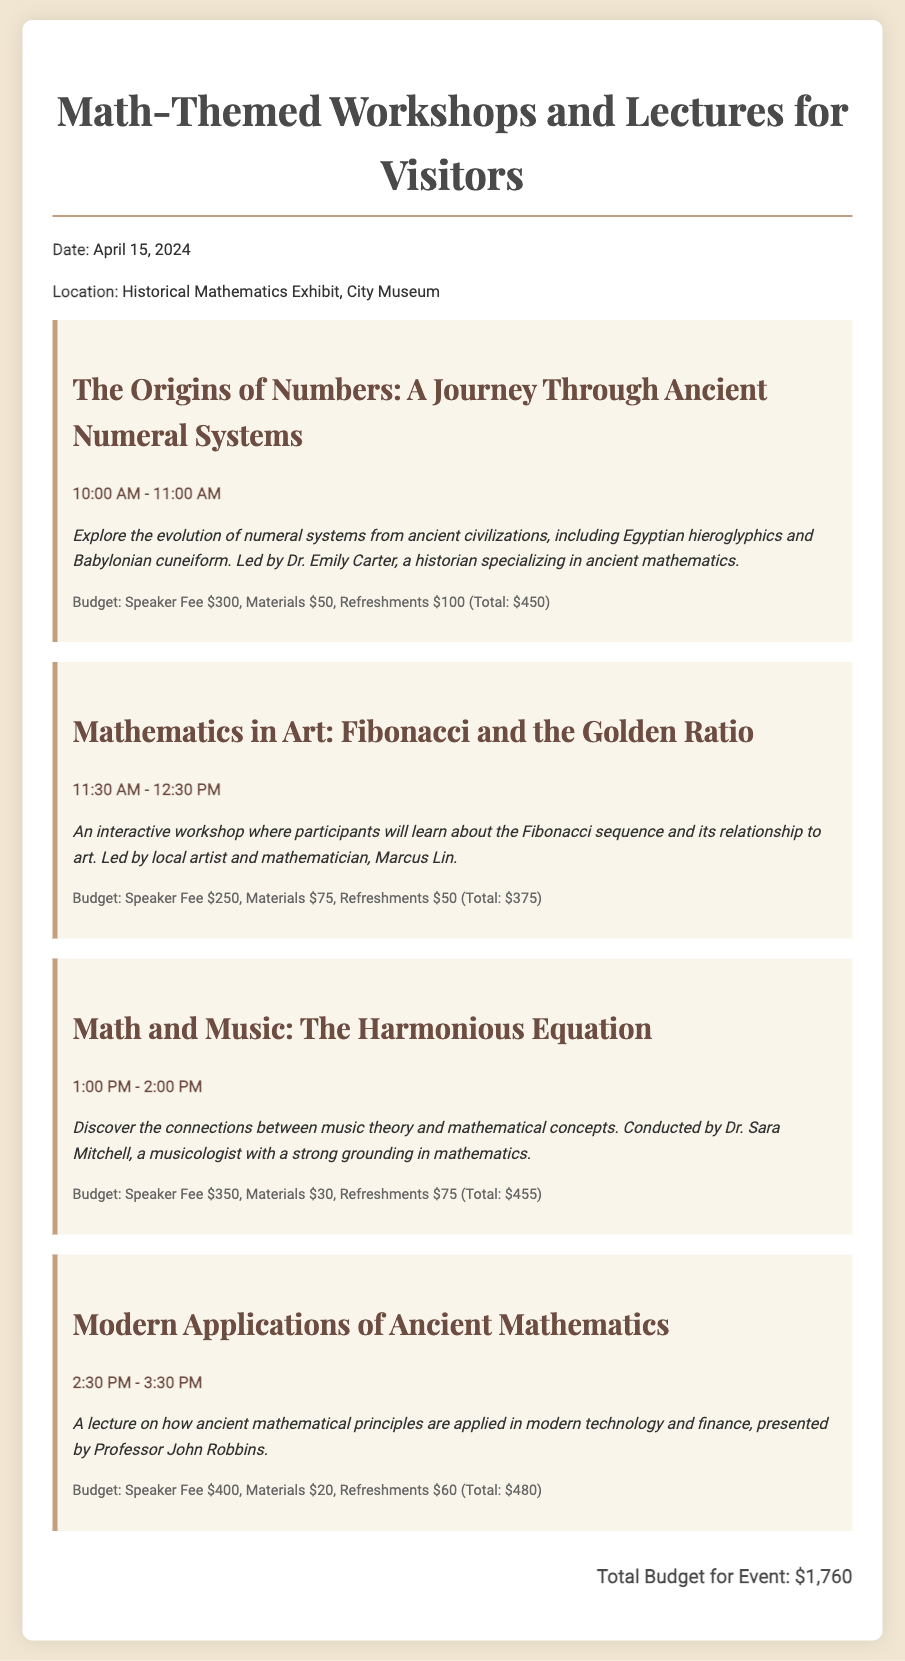What is the date of the event? The event is scheduled for April 15, 2024, as stated in the document.
Answer: April 15, 2024 Who is leading the session on ancient numeral systems? The document specifies that Dr. Emily Carter leads the session on ancient numeral systems.
Answer: Dr. Emily Carter What is the total budget for the event? The document provides a total budget at the end, which sums all session costs.
Answer: $1,760 What time does the session on Mathematics in Art begin? The session on Mathematics in Art starts at 11:30 AM, as mentioned in the schedule.
Answer: 11:30 AM How much is allocated for refreshments in the session about Math and Music? The budget for refreshments in the Math and Music session is clearly stated in the document.
Answer: $75 Which speaker has the highest fee? By comparing the speaker fees listed, it is evident that Professor John Robbins has the highest fee.
Answer: Professor John Robbins How long is the workshop on the Fibonacci sequence? The length of the workshop is provided in the schedule as part of its details.
Answer: 1 hour What is the main theme of the lecture by Professor John Robbins? The document mentions that the lecture focuses on ancient mathematical principles in modern technology.
Answer: Modern Applications of Ancient Mathematics What is the budget for materials in the session on Math and Music? The materials cost for the Math and Music session is noted in the budget section of that session.
Answer: $30 